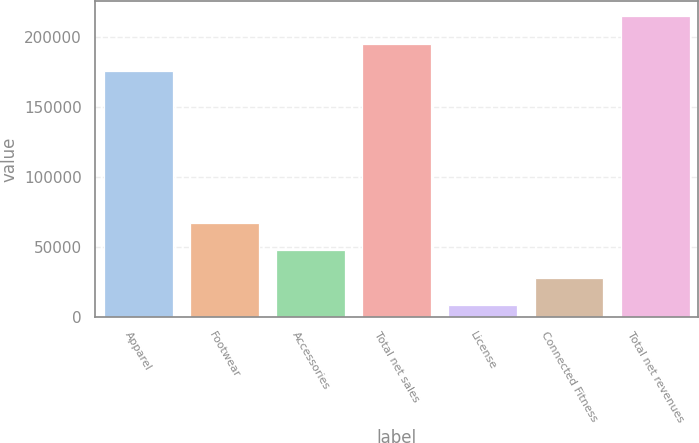Convert chart. <chart><loc_0><loc_0><loc_500><loc_500><bar_chart><fcel>Apparel<fcel>Footwear<fcel>Accessories<fcel>Total net sales<fcel>License<fcel>Connected Fitness<fcel>Total net revenues<nl><fcel>175251<fcel>66929.3<fcel>47356.2<fcel>194824<fcel>8210<fcel>27783.1<fcel>214397<nl></chart> 